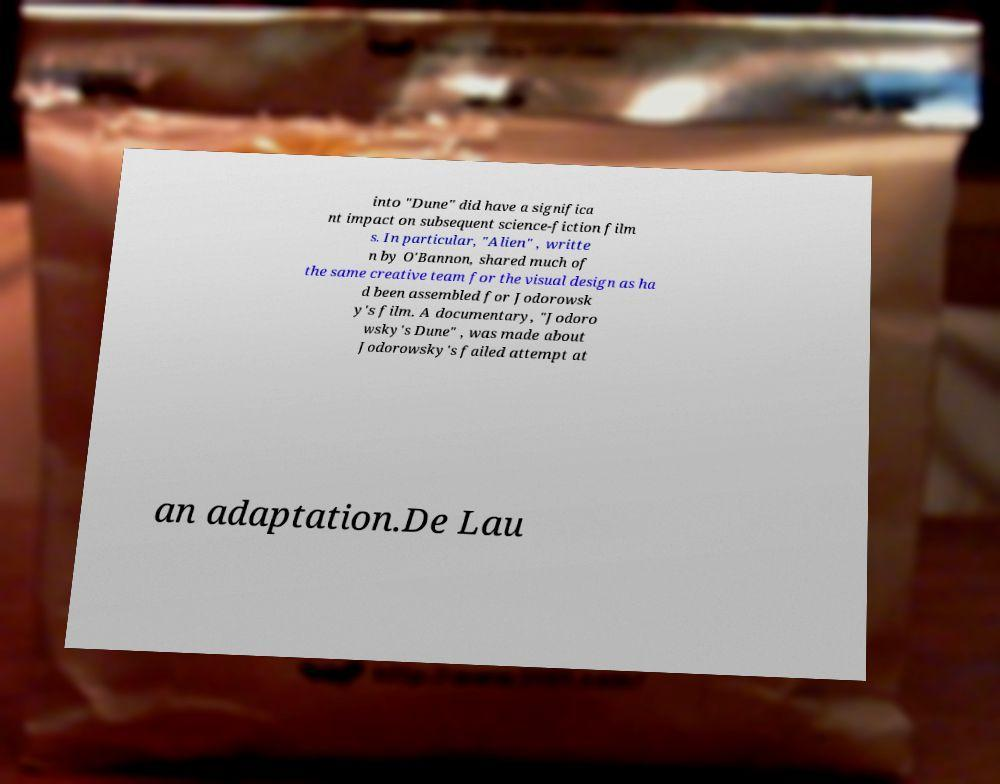Can you accurately transcribe the text from the provided image for me? into "Dune" did have a significa nt impact on subsequent science-fiction film s. In particular, "Alien" , writte n by O'Bannon, shared much of the same creative team for the visual design as ha d been assembled for Jodorowsk y's film. A documentary, "Jodoro wsky's Dune" , was made about Jodorowsky's failed attempt at an adaptation.De Lau 